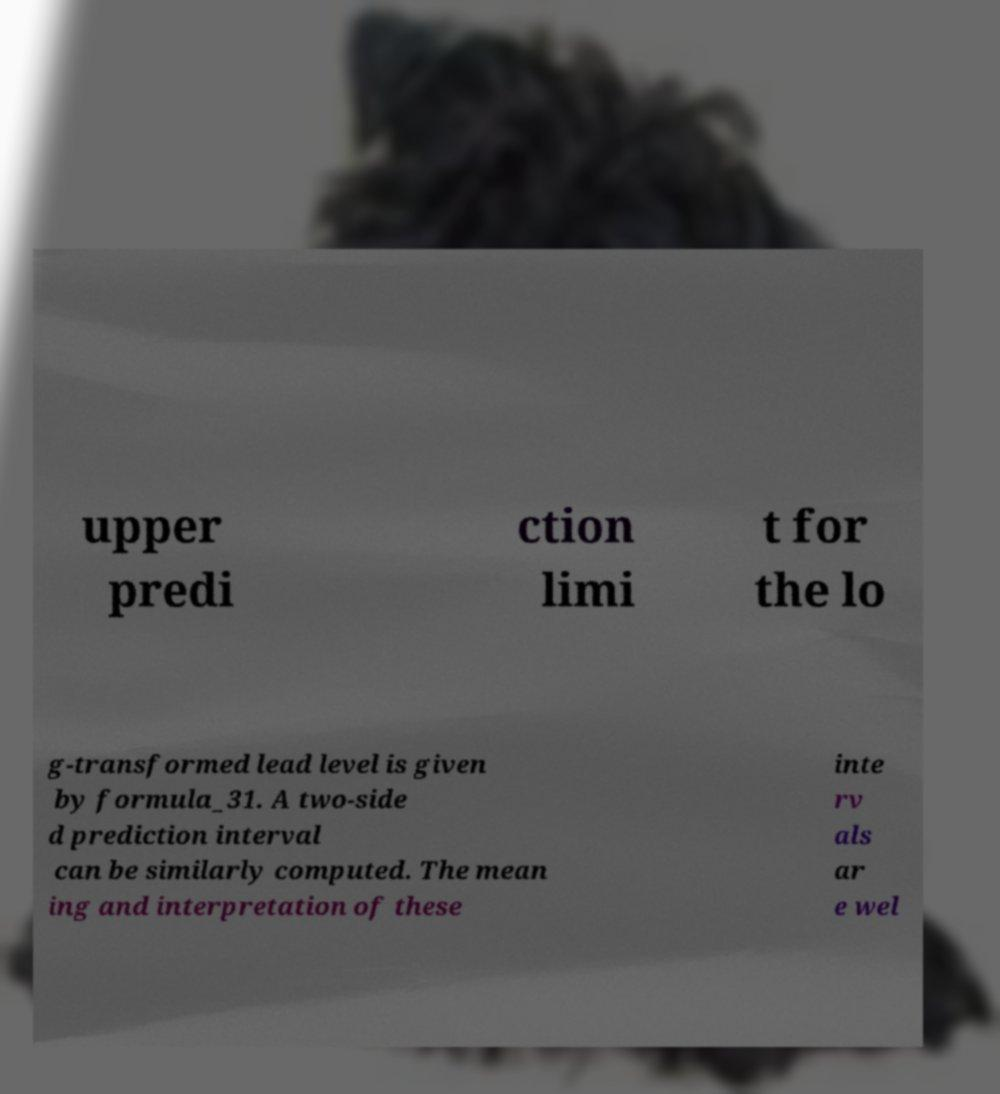There's text embedded in this image that I need extracted. Can you transcribe it verbatim? upper predi ction limi t for the lo g-transformed lead level is given by formula_31. A two-side d prediction interval can be similarly computed. The mean ing and interpretation of these inte rv als ar e wel 